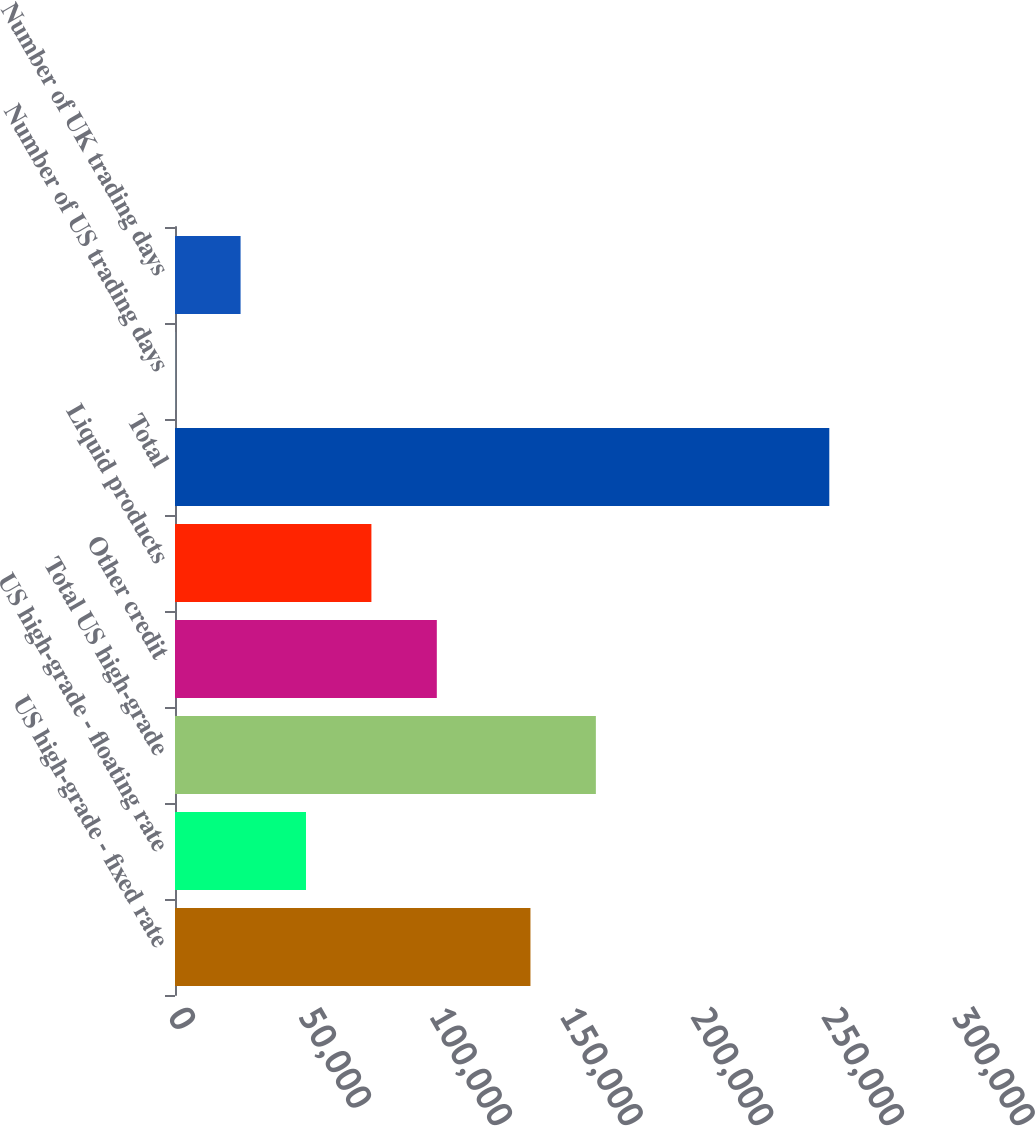Convert chart to OTSL. <chart><loc_0><loc_0><loc_500><loc_500><bar_chart><fcel>US high-grade - fixed rate<fcel>US high-grade - floating rate<fcel>Total US high-grade<fcel>Other credit<fcel>Liquid products<fcel>Total<fcel>Number of US trading days<fcel>Number of UK trading days<nl><fcel>136015<fcel>50123.6<fcel>161046<fcel>100185<fcel>75154.4<fcel>250370<fcel>62<fcel>25092.8<nl></chart> 